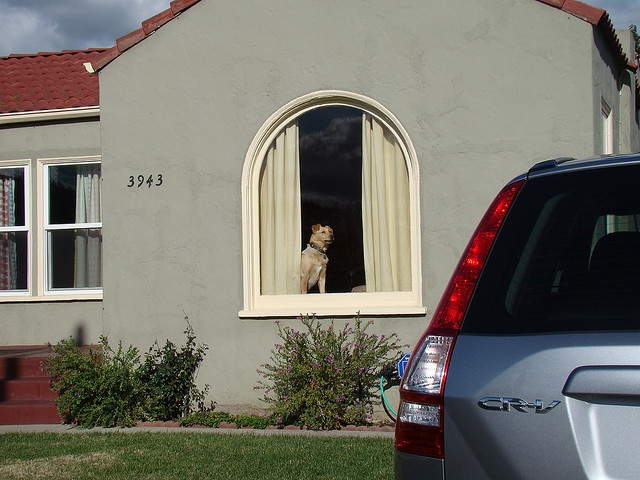Describe the objects in this image and their specific colors. I can see car in gray, black, darkgray, and darkblue tones and dog in gray and tan tones in this image. 